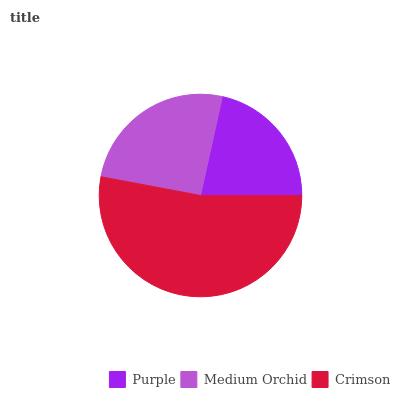Is Purple the minimum?
Answer yes or no. Yes. Is Crimson the maximum?
Answer yes or no. Yes. Is Medium Orchid the minimum?
Answer yes or no. No. Is Medium Orchid the maximum?
Answer yes or no. No. Is Medium Orchid greater than Purple?
Answer yes or no. Yes. Is Purple less than Medium Orchid?
Answer yes or no. Yes. Is Purple greater than Medium Orchid?
Answer yes or no. No. Is Medium Orchid less than Purple?
Answer yes or no. No. Is Medium Orchid the high median?
Answer yes or no. Yes. Is Medium Orchid the low median?
Answer yes or no. Yes. Is Purple the high median?
Answer yes or no. No. Is Crimson the low median?
Answer yes or no. No. 